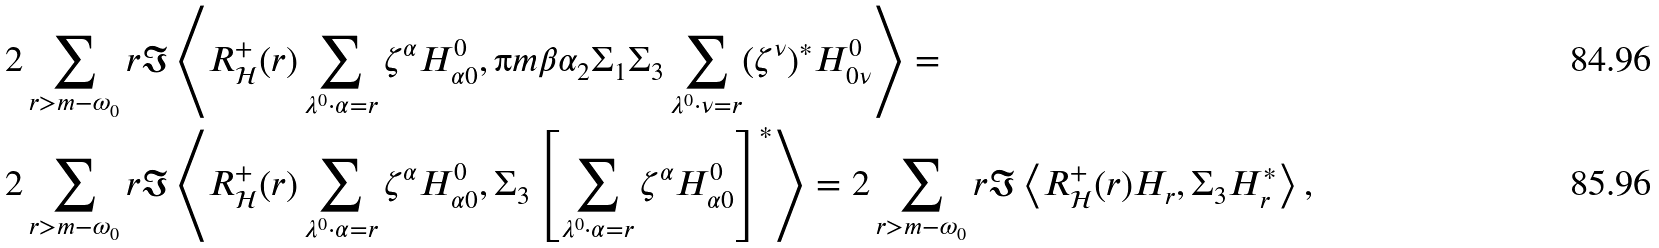<formula> <loc_0><loc_0><loc_500><loc_500>& 2 \sum _ { r > m - \omega _ { 0 } } r \Im \left \langle R _ { \mathcal { H } } ^ { + } ( r ) \sum _ { \lambda ^ { 0 } \cdot \alpha = r } \zeta ^ { \alpha } H _ { \alpha 0 } ^ { 0 } , \i m \beta \alpha _ { 2 } \Sigma _ { 1 } \Sigma _ { 3 } \sum _ { \lambda ^ { 0 } \cdot \nu = r } ( { \zeta } ^ { \nu } ) ^ { * } H ^ { 0 } _ { 0 \nu } \right \rangle = \\ & 2 \sum _ { r > m - \omega _ { 0 } } r \Im \left \langle R _ { \mathcal { H } } ^ { + } ( r ) \sum _ { \lambda ^ { 0 } \cdot \alpha = r } \zeta ^ { \alpha } H _ { \alpha 0 } ^ { 0 } , \Sigma _ { 3 } \left [ \sum _ { \lambda ^ { 0 } \cdot \alpha = r } \zeta ^ { \alpha } H ^ { 0 } _ { \alpha 0 } \right ] ^ { * } \right \rangle = 2 \sum _ { r > m - \omega _ { 0 } } r \Im \left \langle R _ { \mathcal { H } } ^ { + } ( r ) H _ { r } , \Sigma _ { 3 } H _ { r } ^ { * } \right \rangle ,</formula> 